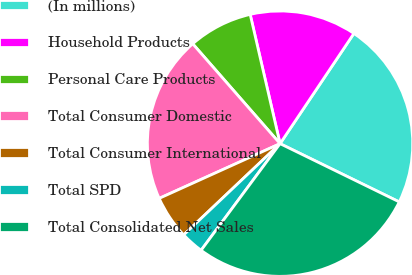<chart> <loc_0><loc_0><loc_500><loc_500><pie_chart><fcel>(In millions)<fcel>Household Products<fcel>Personal Care Products<fcel>Total Consumer Domestic<fcel>Total Consumer International<fcel>Total SPD<fcel>Total Consolidated Net Sales<nl><fcel>22.84%<fcel>13.01%<fcel>7.82%<fcel>20.33%<fcel>5.3%<fcel>2.79%<fcel>27.91%<nl></chart> 